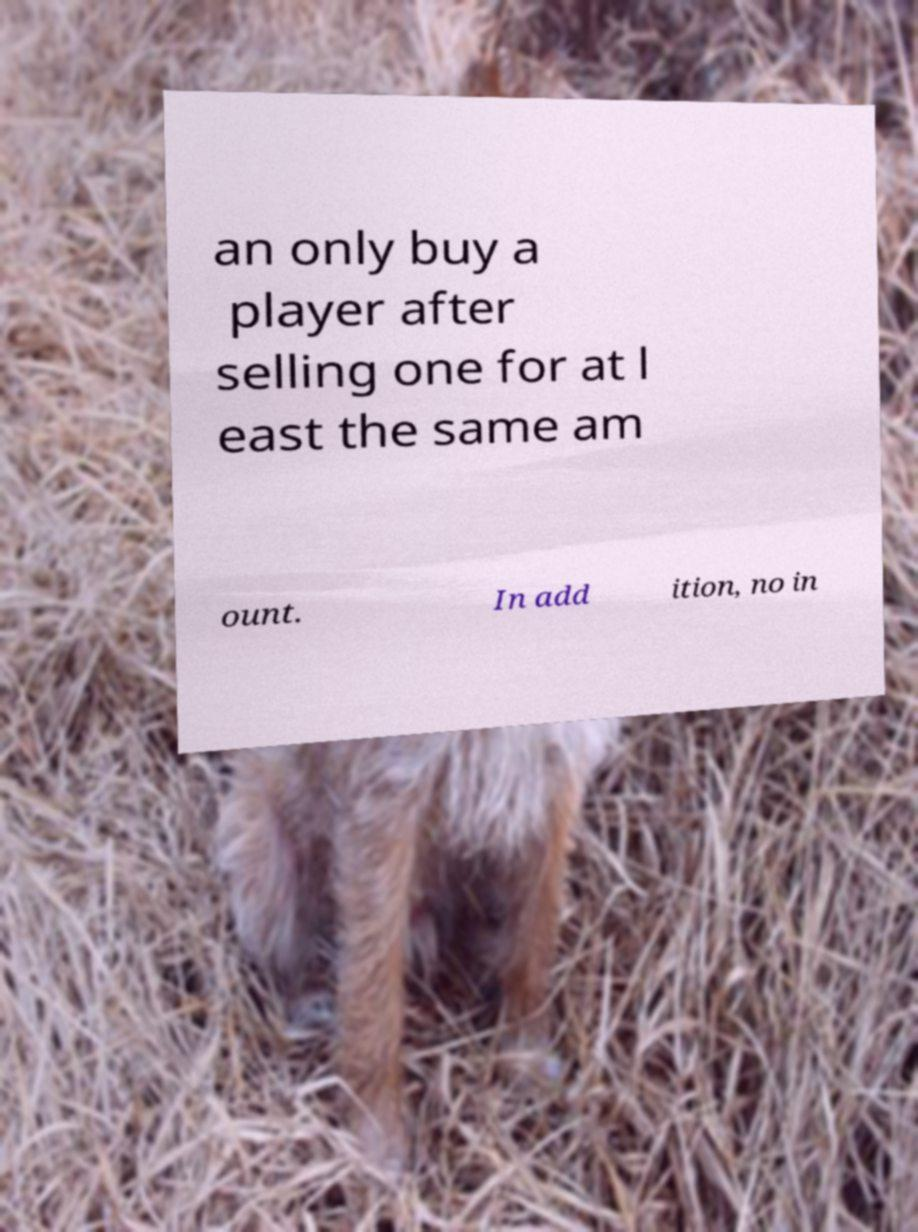Could you extract and type out the text from this image? an only buy a player after selling one for at l east the same am ount. In add ition, no in 